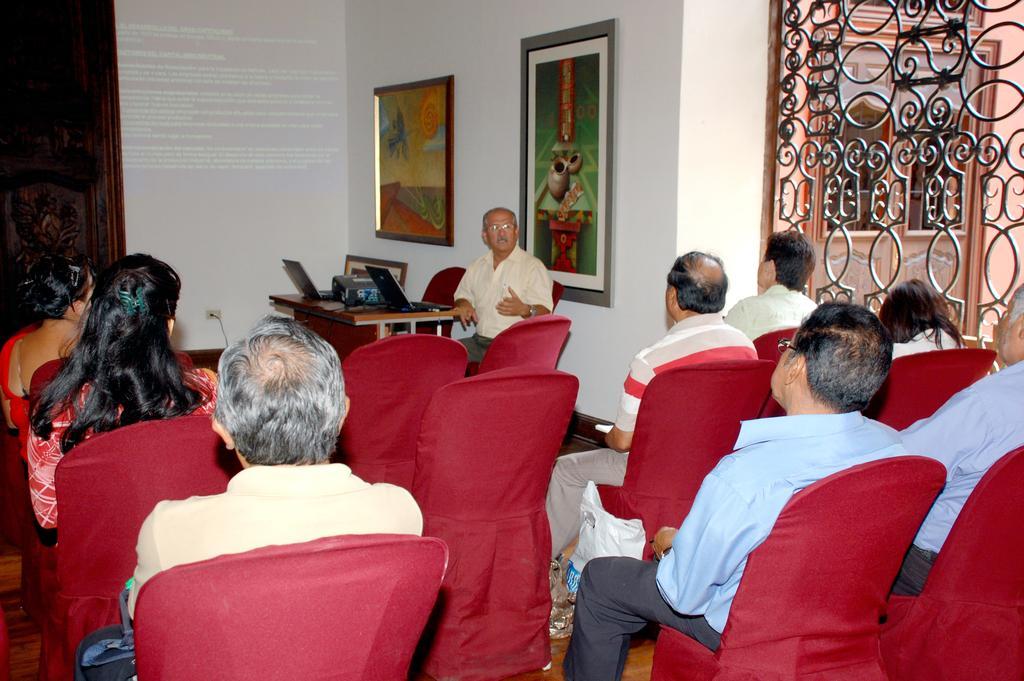Can you describe this image briefly? In this picture there are a group of people sitting on the chairs, there are also some empty chairs. There is a man sitting over here and he is looking at the people in front of them. In the backdrop there is a wall used as a projector screen, and there is a photo frame. 